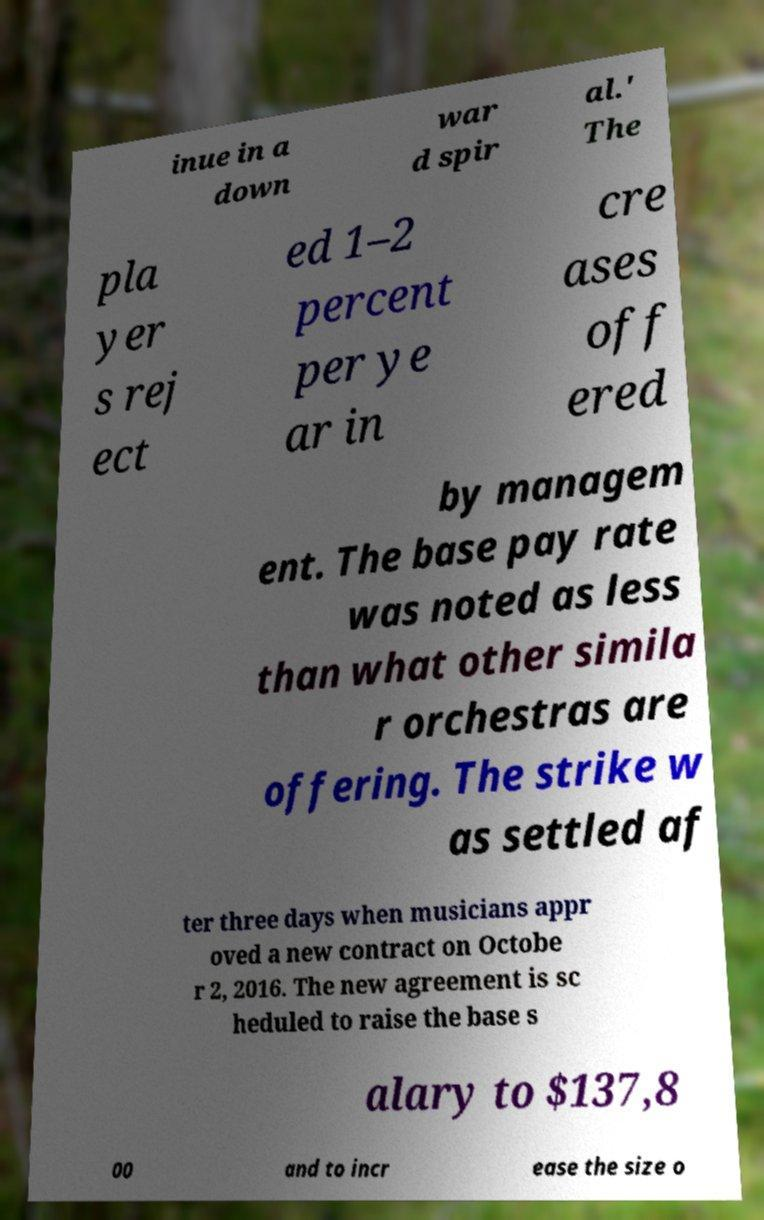I need the written content from this picture converted into text. Can you do that? inue in a down war d spir al.' The pla yer s rej ect ed 1–2 percent per ye ar in cre ases off ered by managem ent. The base pay rate was noted as less than what other simila r orchestras are offering. The strike w as settled af ter three days when musicians appr oved a new contract on Octobe r 2, 2016. The new agreement is sc heduled to raise the base s alary to $137,8 00 and to incr ease the size o 